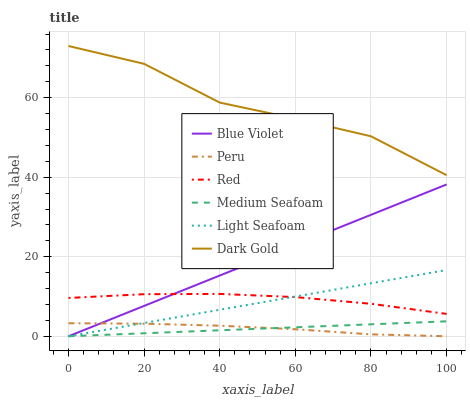Does Blue Violet have the minimum area under the curve?
Answer yes or no. No. Does Blue Violet have the maximum area under the curve?
Answer yes or no. No. Is Blue Violet the smoothest?
Answer yes or no. No. Is Blue Violet the roughest?
Answer yes or no. No. Does Red have the lowest value?
Answer yes or no. No. Does Blue Violet have the highest value?
Answer yes or no. No. Is Red less than Dark Gold?
Answer yes or no. Yes. Is Dark Gold greater than Light Seafoam?
Answer yes or no. Yes. Does Red intersect Dark Gold?
Answer yes or no. No. 